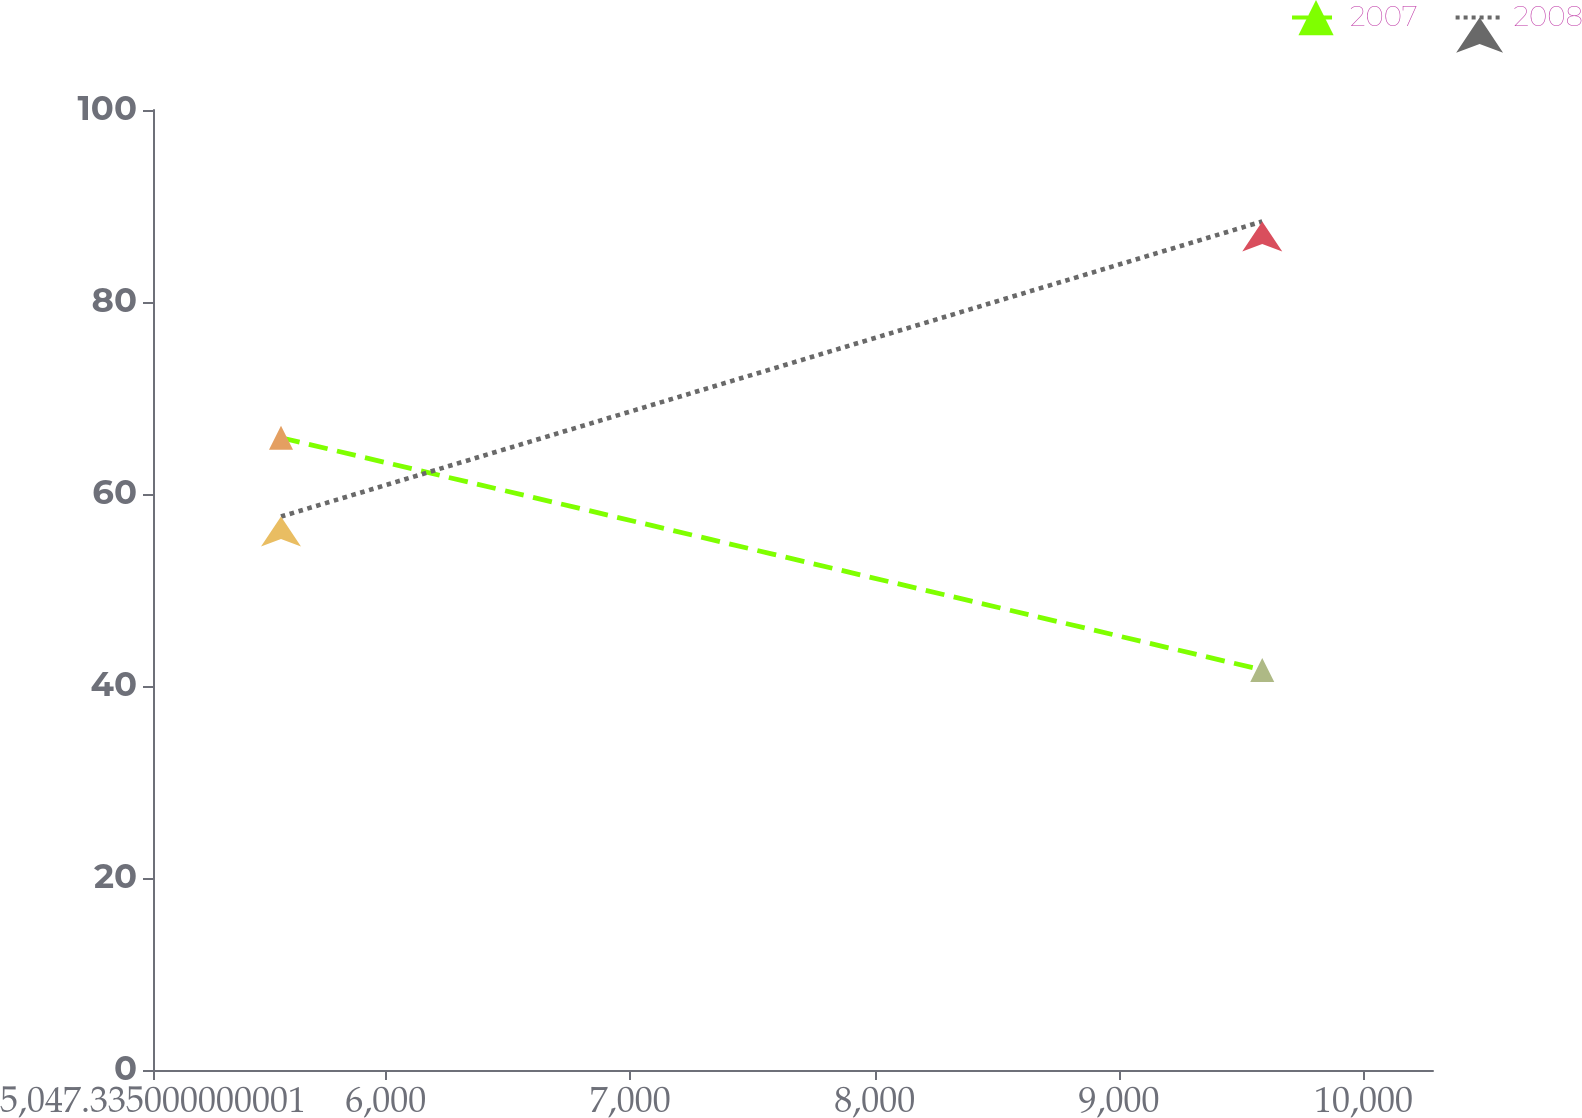Convert chart to OTSL. <chart><loc_0><loc_0><loc_500><loc_500><line_chart><ecel><fcel>2007<fcel>2008<nl><fcel>5571.06<fcel>65.86<fcel>57.65<nl><fcel>9585.96<fcel>41.67<fcel>88.39<nl><fcel>10808.3<fcel>21.08<fcel>65.96<nl></chart> 